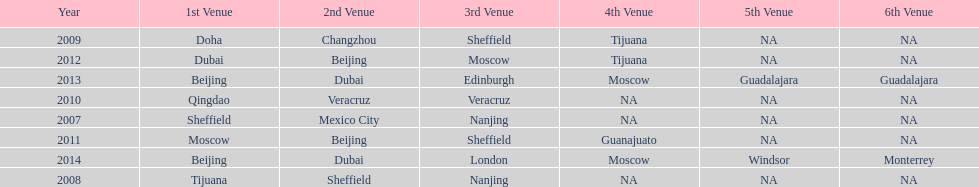Which year had more venues, 2007 or 2012? 2012. 